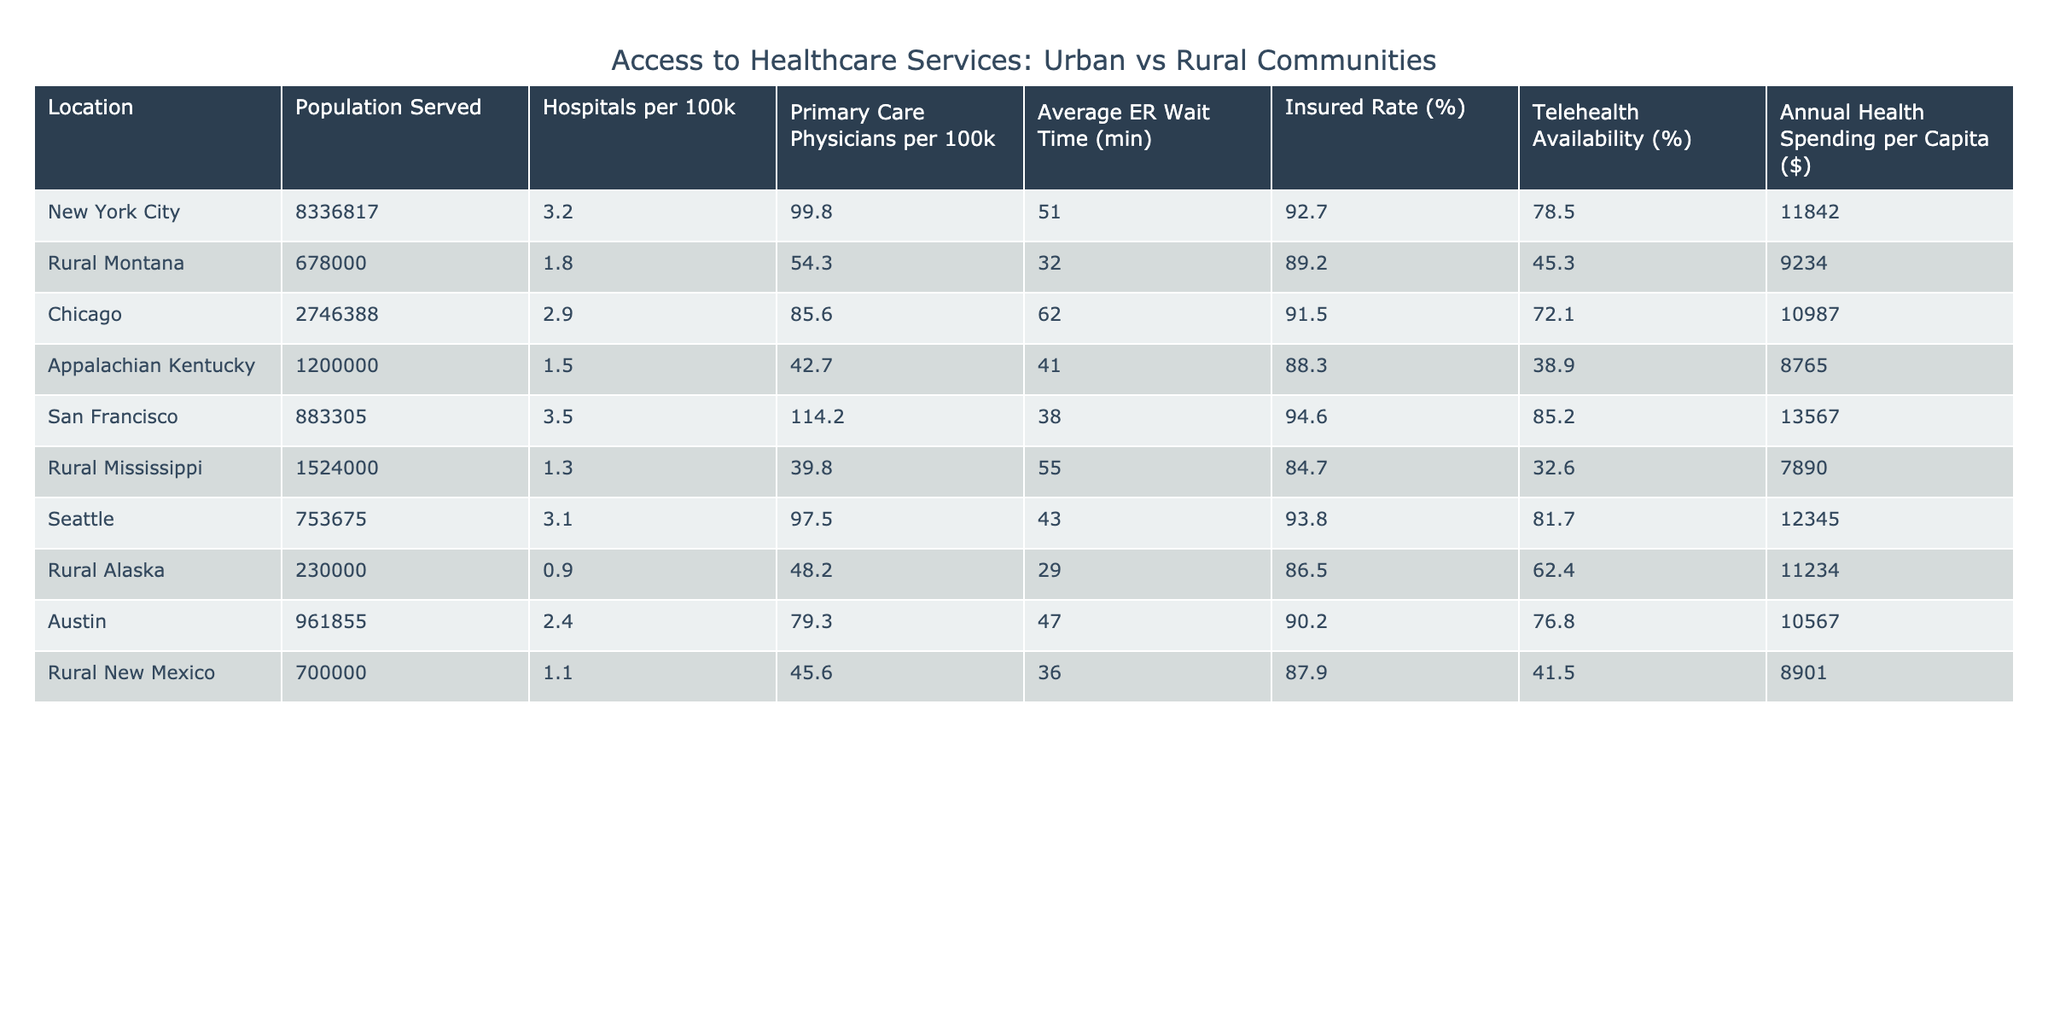What is the population served by San Francisco? The table shows that the population served by San Francisco is clearly indicated as 883,305.
Answer: 883,305 Which location has the highest number of primary care physicians per 100k? According to the table, San Francisco has 114.2 primary care physicians per 100k, which is the highest among the listed locations.
Answer: San Francisco What is the average emergency room wait time in Rural Montana? The table lists the average ER wait time in Rural Montana as 32 minutes.
Answer: 32 minutes How many hospitals per 100k are there in Chicago compared to Rural Alaska? Chicago has 2.9 hospitals per 100k, while Rural Alaska has only 0.9, so Chicago has more hospitals.
Answer: Chicago has more hospitals Which community has the lowest insured rate percentage? The insured rate percentage for Rural Mississippi is 84.7%, which is the lowest compared to the other locations in the table.
Answer: Rural Mississippi Calculate the average annual health spending per capita for rural communities in the table. The rural communities listed are Rural Montana, Appalachian Kentucky, Rural Mississippi, Rural Alaska, and Rural New Mexico. Their annual health spending per capita amounts are $9,234, $8,765, $7,890, $11,234, and $8,901, respectively. Summing these values gives $45,024, and dividing by 5 yields an average of $9,004.80.
Answer: $9,004.80 Is the telehealth availability higher in New York City or in Chicago? According to the table, New York City has a telehealth availability of 78.5%, while Chicago has 72.1%. New York City has higher availability.
Answer: New York City Which location has the highest average ER wait time? The table indicates that Chicago has the highest average ER wait time at 62 minutes, making it the location with the most extended wait.
Answer: Chicago If the annual health spending per capita in New York City is compared to Rural Mississippi, which is higher and by how much? New York City's annual health spending is $11,842, while Rural Mississippi's is $7,890. The difference is $11,842 - $7,890 = $3,952, thus, New York City has higher spending by $3,952.
Answer: New York City by $3,952 What percentage of the population in Appalachian Kentucky is insured? The table shows that the insured rate for Appalachian Kentucky is 88.3%.
Answer: 88.3% 